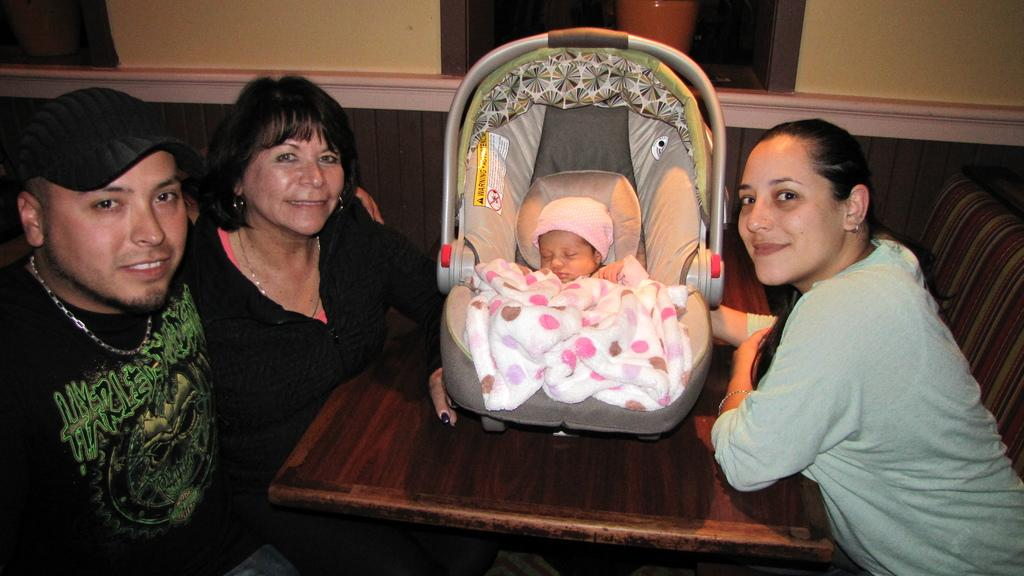How many people are present in the image? There are three people in the image. What is the facial expression of the people in the image? All three people are smiling. What is the baby in the image doing? The baby is in a stroller in the middle of the image. What can be seen in the background of the image? There is a wall in the background of the image. What type of cherry is being used as a prop in the image? There is no cherry present in the image. What facial feature is missing from the people in the image? The people in the image have complete faces, so no facial feature is missing. 